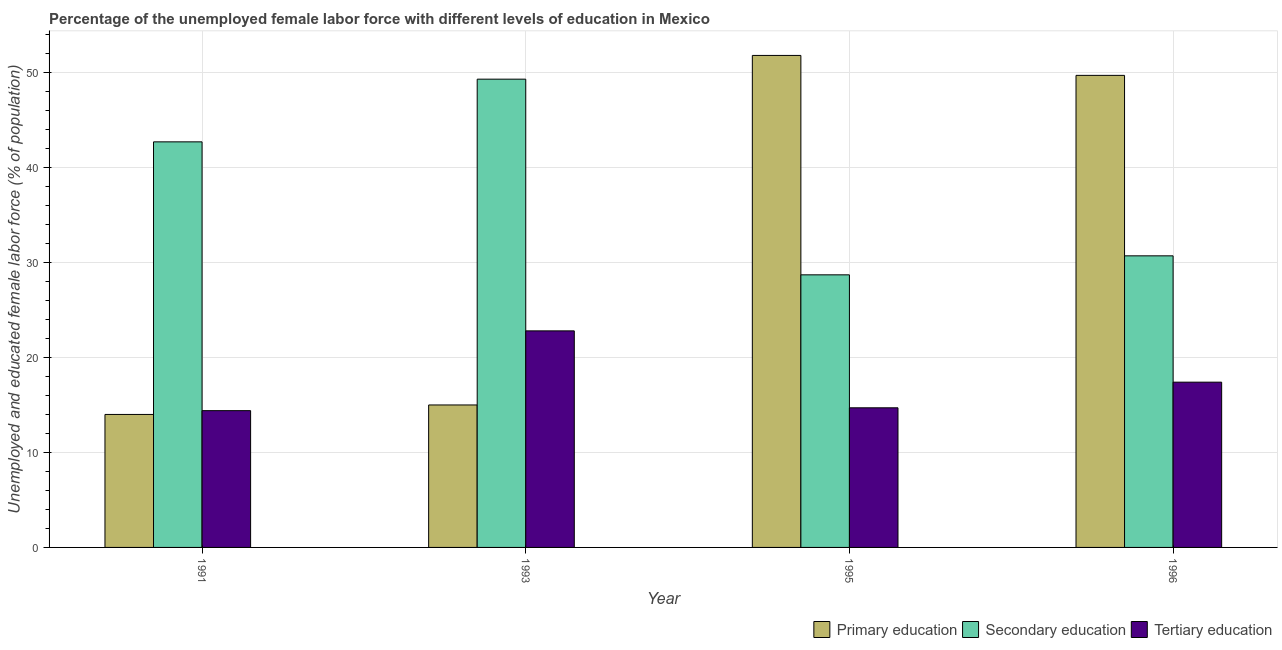How many different coloured bars are there?
Provide a succinct answer. 3. How many groups of bars are there?
Ensure brevity in your answer.  4. Are the number of bars per tick equal to the number of legend labels?
Provide a succinct answer. Yes. What is the label of the 2nd group of bars from the left?
Ensure brevity in your answer.  1993. In how many cases, is the number of bars for a given year not equal to the number of legend labels?
Offer a terse response. 0. What is the percentage of female labor force who received secondary education in 1995?
Your answer should be compact. 28.7. Across all years, what is the maximum percentage of female labor force who received primary education?
Give a very brief answer. 51.8. Across all years, what is the minimum percentage of female labor force who received tertiary education?
Offer a very short reply. 14.4. What is the total percentage of female labor force who received secondary education in the graph?
Keep it short and to the point. 151.4. What is the difference between the percentage of female labor force who received primary education in 1995 and that in 1996?
Your answer should be very brief. 2.1. What is the difference between the percentage of female labor force who received tertiary education in 1996 and the percentage of female labor force who received secondary education in 1993?
Ensure brevity in your answer.  -5.4. What is the average percentage of female labor force who received tertiary education per year?
Your answer should be very brief. 17.32. In how many years, is the percentage of female labor force who received secondary education greater than 14 %?
Your response must be concise. 4. What is the ratio of the percentage of female labor force who received tertiary education in 1995 to that in 1996?
Provide a succinct answer. 0.84. What is the difference between the highest and the second highest percentage of female labor force who received primary education?
Offer a very short reply. 2.1. What is the difference between the highest and the lowest percentage of female labor force who received primary education?
Offer a terse response. 37.8. In how many years, is the percentage of female labor force who received secondary education greater than the average percentage of female labor force who received secondary education taken over all years?
Keep it short and to the point. 2. Is the sum of the percentage of female labor force who received secondary education in 1991 and 1996 greater than the maximum percentage of female labor force who received tertiary education across all years?
Offer a very short reply. Yes. What does the 1st bar from the left in 1993 represents?
Your answer should be very brief. Primary education. How many bars are there?
Offer a terse response. 12. How many years are there in the graph?
Provide a short and direct response. 4. What is the difference between two consecutive major ticks on the Y-axis?
Ensure brevity in your answer.  10. Are the values on the major ticks of Y-axis written in scientific E-notation?
Your answer should be compact. No. Does the graph contain any zero values?
Offer a very short reply. No. Does the graph contain grids?
Provide a succinct answer. Yes. Where does the legend appear in the graph?
Offer a terse response. Bottom right. What is the title of the graph?
Keep it short and to the point. Percentage of the unemployed female labor force with different levels of education in Mexico. Does "Taxes on income" appear as one of the legend labels in the graph?
Your response must be concise. No. What is the label or title of the X-axis?
Give a very brief answer. Year. What is the label or title of the Y-axis?
Ensure brevity in your answer.  Unemployed and educated female labor force (% of population). What is the Unemployed and educated female labor force (% of population) of Primary education in 1991?
Provide a short and direct response. 14. What is the Unemployed and educated female labor force (% of population) in Secondary education in 1991?
Give a very brief answer. 42.7. What is the Unemployed and educated female labor force (% of population) in Tertiary education in 1991?
Provide a succinct answer. 14.4. What is the Unemployed and educated female labor force (% of population) in Secondary education in 1993?
Provide a succinct answer. 49.3. What is the Unemployed and educated female labor force (% of population) of Tertiary education in 1993?
Provide a succinct answer. 22.8. What is the Unemployed and educated female labor force (% of population) in Primary education in 1995?
Provide a succinct answer. 51.8. What is the Unemployed and educated female labor force (% of population) of Secondary education in 1995?
Your answer should be very brief. 28.7. What is the Unemployed and educated female labor force (% of population) of Tertiary education in 1995?
Provide a short and direct response. 14.7. What is the Unemployed and educated female labor force (% of population) of Primary education in 1996?
Give a very brief answer. 49.7. What is the Unemployed and educated female labor force (% of population) in Secondary education in 1996?
Give a very brief answer. 30.7. What is the Unemployed and educated female labor force (% of population) of Tertiary education in 1996?
Offer a very short reply. 17.4. Across all years, what is the maximum Unemployed and educated female labor force (% of population) in Primary education?
Your response must be concise. 51.8. Across all years, what is the maximum Unemployed and educated female labor force (% of population) in Secondary education?
Your answer should be compact. 49.3. Across all years, what is the maximum Unemployed and educated female labor force (% of population) in Tertiary education?
Your answer should be compact. 22.8. Across all years, what is the minimum Unemployed and educated female labor force (% of population) in Primary education?
Offer a terse response. 14. Across all years, what is the minimum Unemployed and educated female labor force (% of population) of Secondary education?
Provide a short and direct response. 28.7. Across all years, what is the minimum Unemployed and educated female labor force (% of population) in Tertiary education?
Offer a terse response. 14.4. What is the total Unemployed and educated female labor force (% of population) of Primary education in the graph?
Offer a very short reply. 130.5. What is the total Unemployed and educated female labor force (% of population) in Secondary education in the graph?
Provide a succinct answer. 151.4. What is the total Unemployed and educated female labor force (% of population) of Tertiary education in the graph?
Keep it short and to the point. 69.3. What is the difference between the Unemployed and educated female labor force (% of population) in Primary education in 1991 and that in 1993?
Keep it short and to the point. -1. What is the difference between the Unemployed and educated female labor force (% of population) in Secondary education in 1991 and that in 1993?
Make the answer very short. -6.6. What is the difference between the Unemployed and educated female labor force (% of population) of Tertiary education in 1991 and that in 1993?
Make the answer very short. -8.4. What is the difference between the Unemployed and educated female labor force (% of population) in Primary education in 1991 and that in 1995?
Provide a short and direct response. -37.8. What is the difference between the Unemployed and educated female labor force (% of population) of Secondary education in 1991 and that in 1995?
Ensure brevity in your answer.  14. What is the difference between the Unemployed and educated female labor force (% of population) of Primary education in 1991 and that in 1996?
Offer a very short reply. -35.7. What is the difference between the Unemployed and educated female labor force (% of population) of Secondary education in 1991 and that in 1996?
Provide a succinct answer. 12. What is the difference between the Unemployed and educated female labor force (% of population) in Primary education in 1993 and that in 1995?
Your answer should be compact. -36.8. What is the difference between the Unemployed and educated female labor force (% of population) of Secondary education in 1993 and that in 1995?
Ensure brevity in your answer.  20.6. What is the difference between the Unemployed and educated female labor force (% of population) in Primary education in 1993 and that in 1996?
Give a very brief answer. -34.7. What is the difference between the Unemployed and educated female labor force (% of population) in Secondary education in 1993 and that in 1996?
Provide a short and direct response. 18.6. What is the difference between the Unemployed and educated female labor force (% of population) of Tertiary education in 1993 and that in 1996?
Your answer should be very brief. 5.4. What is the difference between the Unemployed and educated female labor force (% of population) in Primary education in 1995 and that in 1996?
Your answer should be very brief. 2.1. What is the difference between the Unemployed and educated female labor force (% of population) of Secondary education in 1995 and that in 1996?
Provide a short and direct response. -2. What is the difference between the Unemployed and educated female labor force (% of population) in Primary education in 1991 and the Unemployed and educated female labor force (% of population) in Secondary education in 1993?
Offer a terse response. -35.3. What is the difference between the Unemployed and educated female labor force (% of population) of Primary education in 1991 and the Unemployed and educated female labor force (% of population) of Secondary education in 1995?
Your answer should be very brief. -14.7. What is the difference between the Unemployed and educated female labor force (% of population) of Primary education in 1991 and the Unemployed and educated female labor force (% of population) of Tertiary education in 1995?
Your answer should be compact. -0.7. What is the difference between the Unemployed and educated female labor force (% of population) of Secondary education in 1991 and the Unemployed and educated female labor force (% of population) of Tertiary education in 1995?
Offer a very short reply. 28. What is the difference between the Unemployed and educated female labor force (% of population) of Primary education in 1991 and the Unemployed and educated female labor force (% of population) of Secondary education in 1996?
Ensure brevity in your answer.  -16.7. What is the difference between the Unemployed and educated female labor force (% of population) in Primary education in 1991 and the Unemployed and educated female labor force (% of population) in Tertiary education in 1996?
Keep it short and to the point. -3.4. What is the difference between the Unemployed and educated female labor force (% of population) of Secondary education in 1991 and the Unemployed and educated female labor force (% of population) of Tertiary education in 1996?
Your response must be concise. 25.3. What is the difference between the Unemployed and educated female labor force (% of population) of Primary education in 1993 and the Unemployed and educated female labor force (% of population) of Secondary education in 1995?
Offer a terse response. -13.7. What is the difference between the Unemployed and educated female labor force (% of population) in Secondary education in 1993 and the Unemployed and educated female labor force (% of population) in Tertiary education in 1995?
Keep it short and to the point. 34.6. What is the difference between the Unemployed and educated female labor force (% of population) in Primary education in 1993 and the Unemployed and educated female labor force (% of population) in Secondary education in 1996?
Ensure brevity in your answer.  -15.7. What is the difference between the Unemployed and educated female labor force (% of population) in Secondary education in 1993 and the Unemployed and educated female labor force (% of population) in Tertiary education in 1996?
Your answer should be very brief. 31.9. What is the difference between the Unemployed and educated female labor force (% of population) in Primary education in 1995 and the Unemployed and educated female labor force (% of population) in Secondary education in 1996?
Your response must be concise. 21.1. What is the difference between the Unemployed and educated female labor force (% of population) of Primary education in 1995 and the Unemployed and educated female labor force (% of population) of Tertiary education in 1996?
Ensure brevity in your answer.  34.4. What is the average Unemployed and educated female labor force (% of population) of Primary education per year?
Your answer should be compact. 32.62. What is the average Unemployed and educated female labor force (% of population) of Secondary education per year?
Your response must be concise. 37.85. What is the average Unemployed and educated female labor force (% of population) of Tertiary education per year?
Your answer should be compact. 17.32. In the year 1991, what is the difference between the Unemployed and educated female labor force (% of population) of Primary education and Unemployed and educated female labor force (% of population) of Secondary education?
Provide a succinct answer. -28.7. In the year 1991, what is the difference between the Unemployed and educated female labor force (% of population) of Primary education and Unemployed and educated female labor force (% of population) of Tertiary education?
Your answer should be very brief. -0.4. In the year 1991, what is the difference between the Unemployed and educated female labor force (% of population) in Secondary education and Unemployed and educated female labor force (% of population) in Tertiary education?
Offer a very short reply. 28.3. In the year 1993, what is the difference between the Unemployed and educated female labor force (% of population) of Primary education and Unemployed and educated female labor force (% of population) of Secondary education?
Offer a very short reply. -34.3. In the year 1993, what is the difference between the Unemployed and educated female labor force (% of population) of Secondary education and Unemployed and educated female labor force (% of population) of Tertiary education?
Your answer should be compact. 26.5. In the year 1995, what is the difference between the Unemployed and educated female labor force (% of population) of Primary education and Unemployed and educated female labor force (% of population) of Secondary education?
Give a very brief answer. 23.1. In the year 1995, what is the difference between the Unemployed and educated female labor force (% of population) in Primary education and Unemployed and educated female labor force (% of population) in Tertiary education?
Your answer should be compact. 37.1. In the year 1995, what is the difference between the Unemployed and educated female labor force (% of population) in Secondary education and Unemployed and educated female labor force (% of population) in Tertiary education?
Ensure brevity in your answer.  14. In the year 1996, what is the difference between the Unemployed and educated female labor force (% of population) of Primary education and Unemployed and educated female labor force (% of population) of Secondary education?
Your answer should be very brief. 19. In the year 1996, what is the difference between the Unemployed and educated female labor force (% of population) of Primary education and Unemployed and educated female labor force (% of population) of Tertiary education?
Your answer should be very brief. 32.3. What is the ratio of the Unemployed and educated female labor force (% of population) of Primary education in 1991 to that in 1993?
Your answer should be very brief. 0.93. What is the ratio of the Unemployed and educated female labor force (% of population) of Secondary education in 1991 to that in 1993?
Your answer should be compact. 0.87. What is the ratio of the Unemployed and educated female labor force (% of population) in Tertiary education in 1991 to that in 1993?
Offer a very short reply. 0.63. What is the ratio of the Unemployed and educated female labor force (% of population) of Primary education in 1991 to that in 1995?
Ensure brevity in your answer.  0.27. What is the ratio of the Unemployed and educated female labor force (% of population) of Secondary education in 1991 to that in 1995?
Your response must be concise. 1.49. What is the ratio of the Unemployed and educated female labor force (% of population) in Tertiary education in 1991 to that in 1995?
Offer a very short reply. 0.98. What is the ratio of the Unemployed and educated female labor force (% of population) of Primary education in 1991 to that in 1996?
Offer a very short reply. 0.28. What is the ratio of the Unemployed and educated female labor force (% of population) in Secondary education in 1991 to that in 1996?
Offer a terse response. 1.39. What is the ratio of the Unemployed and educated female labor force (% of population) of Tertiary education in 1991 to that in 1996?
Offer a very short reply. 0.83. What is the ratio of the Unemployed and educated female labor force (% of population) in Primary education in 1993 to that in 1995?
Your answer should be compact. 0.29. What is the ratio of the Unemployed and educated female labor force (% of population) in Secondary education in 1993 to that in 1995?
Give a very brief answer. 1.72. What is the ratio of the Unemployed and educated female labor force (% of population) in Tertiary education in 1993 to that in 1995?
Offer a terse response. 1.55. What is the ratio of the Unemployed and educated female labor force (% of population) in Primary education in 1993 to that in 1996?
Your response must be concise. 0.3. What is the ratio of the Unemployed and educated female labor force (% of population) of Secondary education in 1993 to that in 1996?
Provide a short and direct response. 1.61. What is the ratio of the Unemployed and educated female labor force (% of population) of Tertiary education in 1993 to that in 1996?
Provide a short and direct response. 1.31. What is the ratio of the Unemployed and educated female labor force (% of population) in Primary education in 1995 to that in 1996?
Offer a terse response. 1.04. What is the ratio of the Unemployed and educated female labor force (% of population) in Secondary education in 1995 to that in 1996?
Your response must be concise. 0.93. What is the ratio of the Unemployed and educated female labor force (% of population) in Tertiary education in 1995 to that in 1996?
Your answer should be very brief. 0.84. What is the difference between the highest and the second highest Unemployed and educated female labor force (% of population) of Primary education?
Make the answer very short. 2.1. What is the difference between the highest and the second highest Unemployed and educated female labor force (% of population) in Tertiary education?
Your answer should be compact. 5.4. What is the difference between the highest and the lowest Unemployed and educated female labor force (% of population) in Primary education?
Provide a short and direct response. 37.8. What is the difference between the highest and the lowest Unemployed and educated female labor force (% of population) in Secondary education?
Give a very brief answer. 20.6. What is the difference between the highest and the lowest Unemployed and educated female labor force (% of population) in Tertiary education?
Keep it short and to the point. 8.4. 